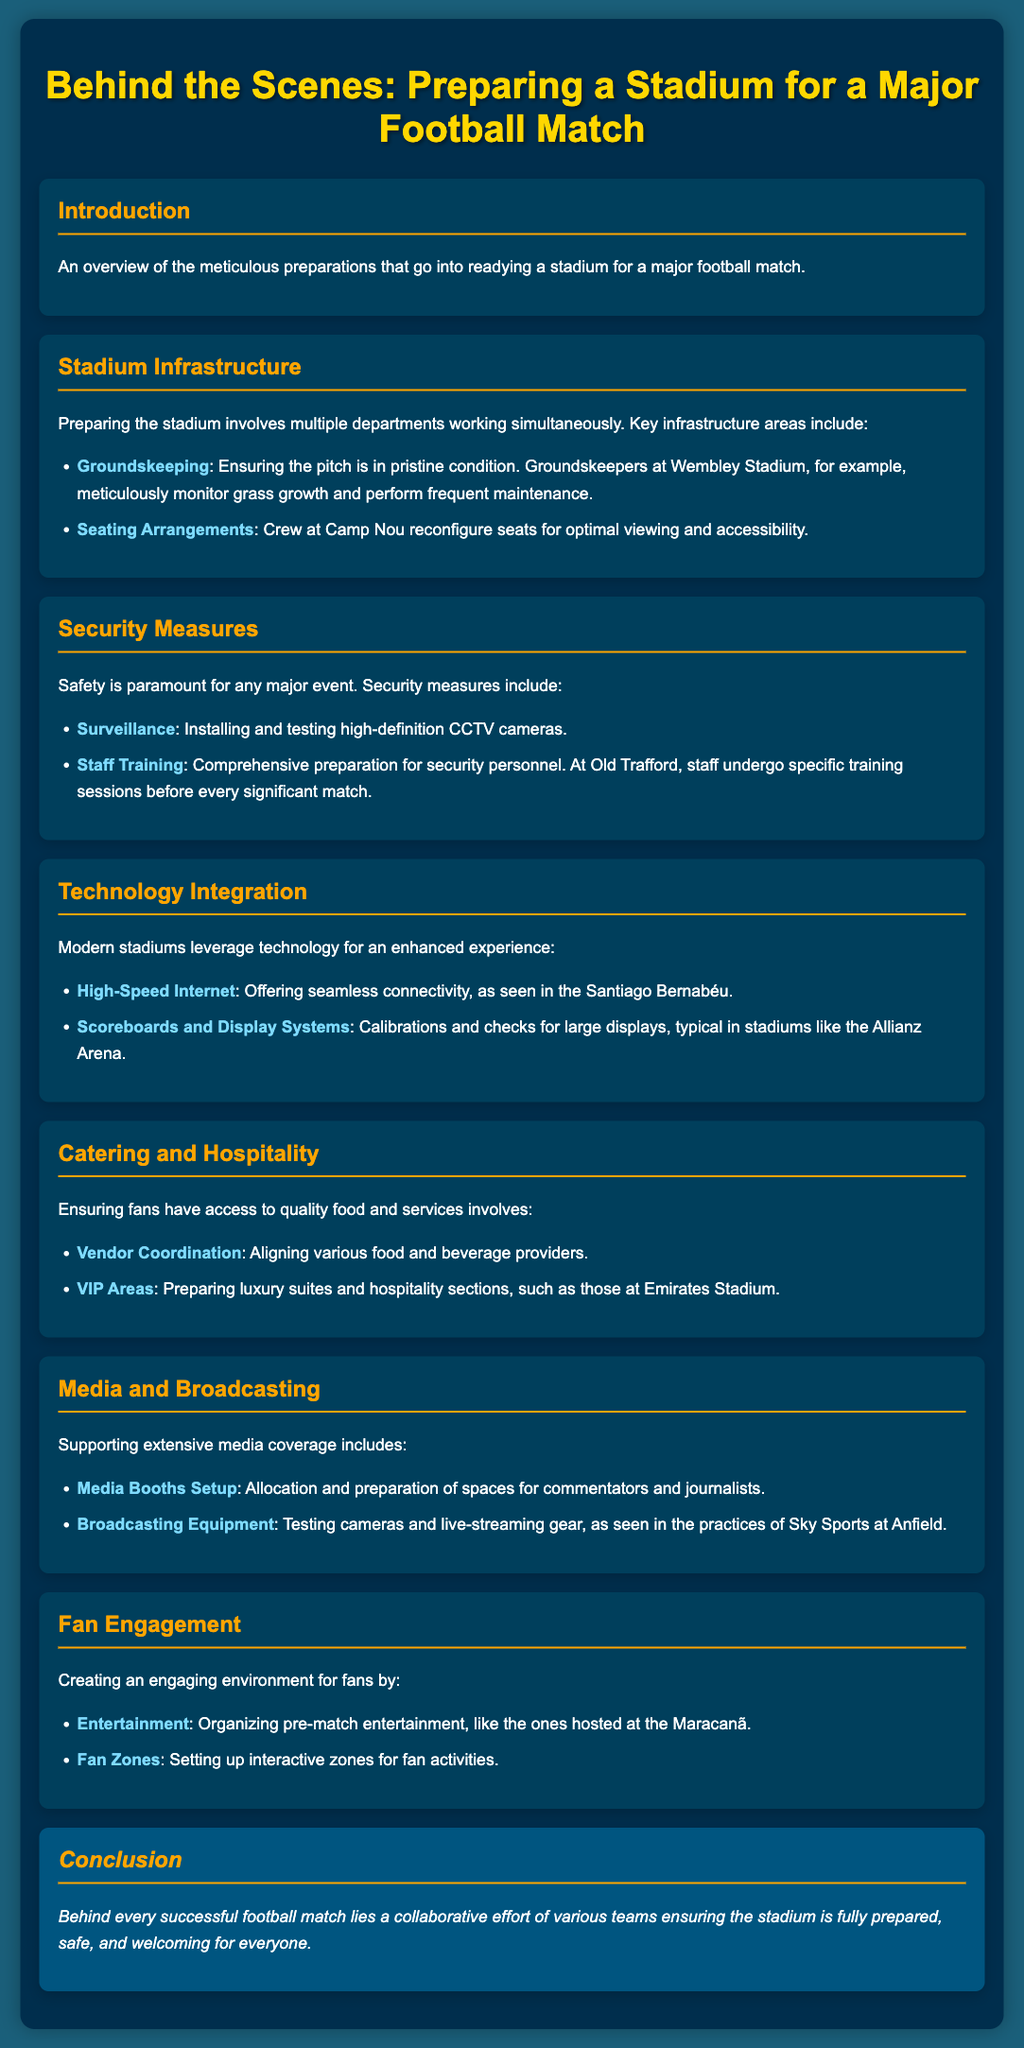what is the title of the presentation? The title of the presentation is given at the top of the document, summarizing the main theme.
Answer: Behind the Scenes: Preparing a Stadium for a Major Football Match who monitors grass growth at Wembley Stadium? This is mentioned under the Groundskeeping section, detailing responsibilities of personnel.
Answer: Groundskeepers what is prepared for optimal viewing at Camp Nou? The presentation specifies actions regarding seating arrangements in relation to fan experience.
Answer: Seating Arrangements what type of training do security personnel undergo? The document references specific preparations for staff before matches to ensure safety protocols are met.
Answer: Comprehensive preparation which stadium features high-speed internet? The mention of technology integration includes examples of modern features found in specific stadiums.
Answer: Santiago Bernabéu what type of environments are created for fans? The Fan Engagement section outlines activities and setup to enhance the experience for attendees.
Answer: Engaging environment what kind of areas are prepared at the Emirates Stadium? The Catering and Hospitality section describes different types of spaces designated for specific fan experiences.
Answer: VIP Areas how many departments work on stadium preparations? The Introduction notes multiple departments involved, indicating the collaborative nature of preparations.
Answer: Multiple departments 